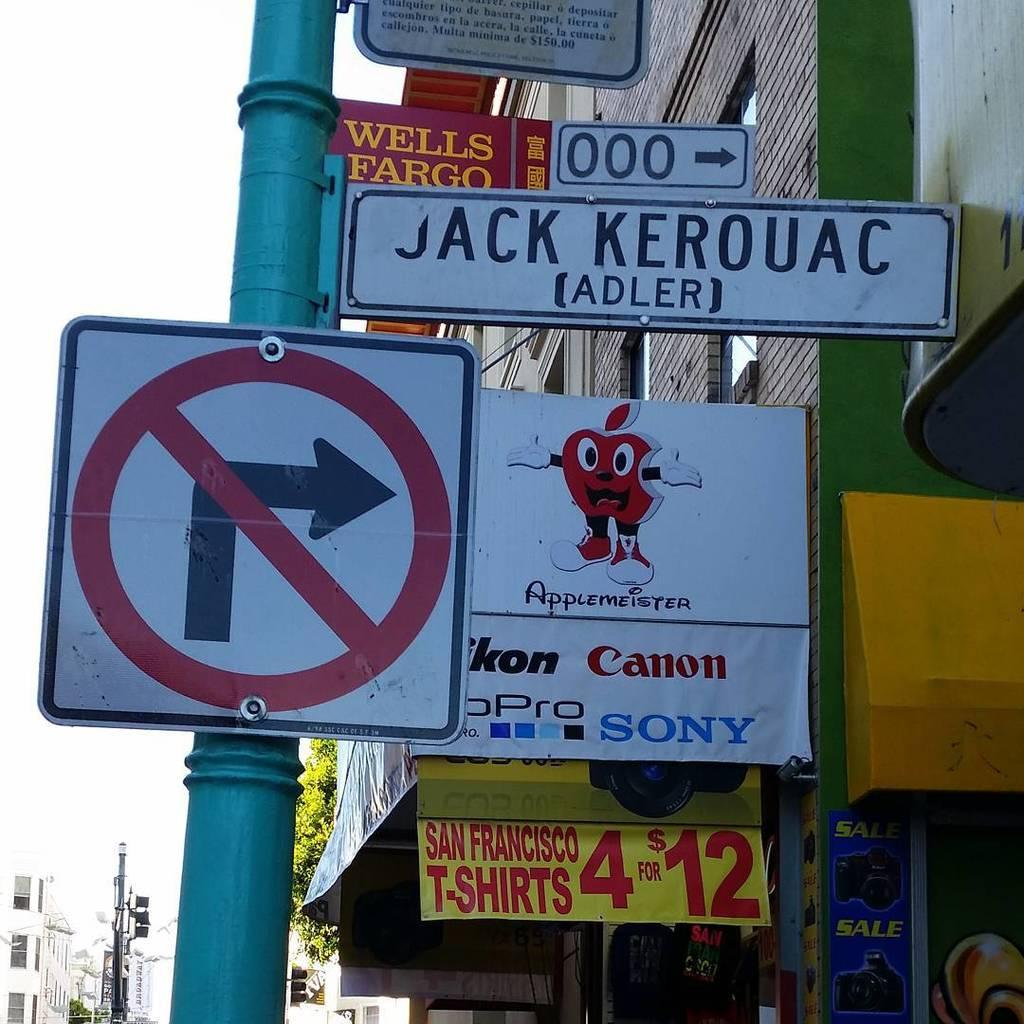<image>
Provide a brief description of the given image. Several street signs with ads in the background for Canon and t-shirts. 